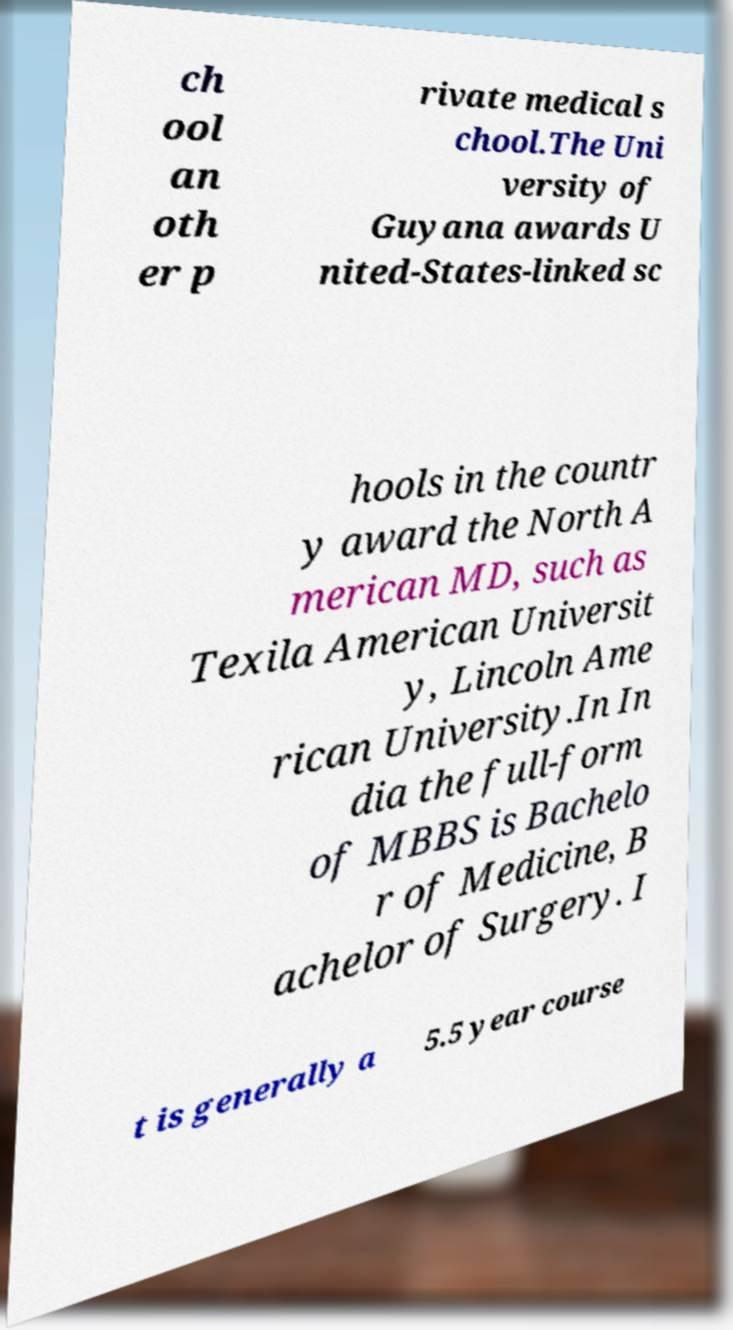There's text embedded in this image that I need extracted. Can you transcribe it verbatim? ch ool an oth er p rivate medical s chool.The Uni versity of Guyana awards U nited-States-linked sc hools in the countr y award the North A merican MD, such as Texila American Universit y, Lincoln Ame rican University.In In dia the full-form of MBBS is Bachelo r of Medicine, B achelor of Surgery. I t is generally a 5.5 year course 